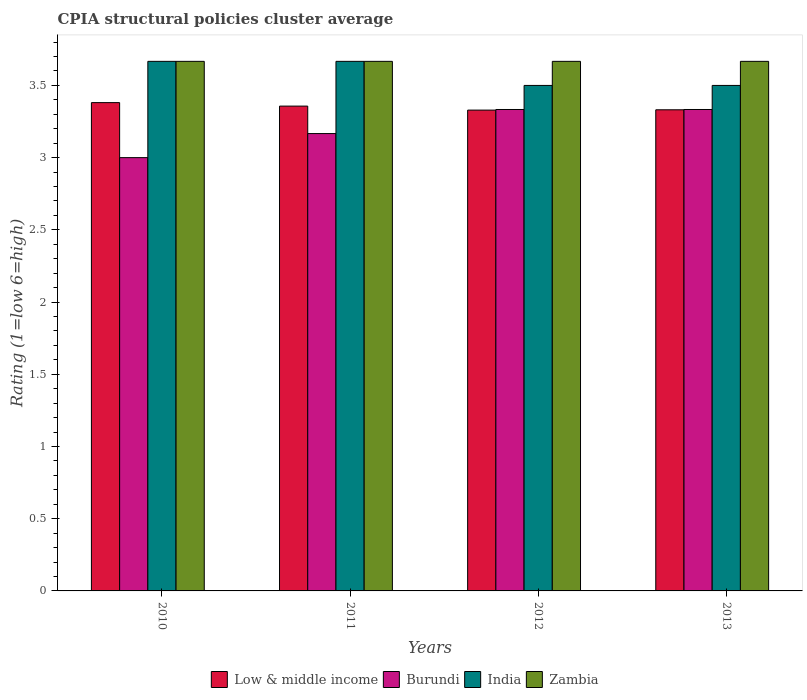What is the label of the 2nd group of bars from the left?
Your response must be concise. 2011. In how many cases, is the number of bars for a given year not equal to the number of legend labels?
Ensure brevity in your answer.  0. What is the CPIA rating in India in 2010?
Provide a short and direct response. 3.67. Across all years, what is the maximum CPIA rating in Zambia?
Offer a terse response. 3.67. In which year was the CPIA rating in India maximum?
Your answer should be very brief. 2010. What is the total CPIA rating in Low & middle income in the graph?
Offer a very short reply. 13.4. What is the difference between the CPIA rating in Low & middle income in 2011 and that in 2012?
Provide a succinct answer. 0.03. What is the difference between the CPIA rating in Zambia in 2010 and the CPIA rating in Low & middle income in 2013?
Provide a short and direct response. 0.34. What is the average CPIA rating in Low & middle income per year?
Ensure brevity in your answer.  3.35. In the year 2011, what is the difference between the CPIA rating in India and CPIA rating in Zambia?
Keep it short and to the point. 0. In how many years, is the CPIA rating in Burundi greater than 1.1?
Your answer should be very brief. 4. What is the ratio of the CPIA rating in Low & middle income in 2012 to that in 2013?
Offer a very short reply. 1. Is the difference between the CPIA rating in India in 2010 and 2013 greater than the difference between the CPIA rating in Zambia in 2010 and 2013?
Give a very brief answer. Yes. What is the difference between the highest and the lowest CPIA rating in Burundi?
Your response must be concise. 0.33. Is it the case that in every year, the sum of the CPIA rating in Burundi and CPIA rating in Zambia is greater than the sum of CPIA rating in Low & middle income and CPIA rating in India?
Keep it short and to the point. No. What does the 4th bar from the left in 2012 represents?
Give a very brief answer. Zambia. What does the 2nd bar from the right in 2012 represents?
Your response must be concise. India. What is the difference between two consecutive major ticks on the Y-axis?
Your response must be concise. 0.5. Does the graph contain any zero values?
Your answer should be very brief. No. How are the legend labels stacked?
Provide a short and direct response. Horizontal. What is the title of the graph?
Ensure brevity in your answer.  CPIA structural policies cluster average. What is the label or title of the X-axis?
Offer a terse response. Years. What is the Rating (1=low 6=high) of Low & middle income in 2010?
Offer a terse response. 3.38. What is the Rating (1=low 6=high) in Burundi in 2010?
Give a very brief answer. 3. What is the Rating (1=low 6=high) of India in 2010?
Offer a very short reply. 3.67. What is the Rating (1=low 6=high) of Zambia in 2010?
Ensure brevity in your answer.  3.67. What is the Rating (1=low 6=high) in Low & middle income in 2011?
Provide a short and direct response. 3.36. What is the Rating (1=low 6=high) of Burundi in 2011?
Your response must be concise. 3.17. What is the Rating (1=low 6=high) of India in 2011?
Offer a very short reply. 3.67. What is the Rating (1=low 6=high) of Zambia in 2011?
Provide a succinct answer. 3.67. What is the Rating (1=low 6=high) of Low & middle income in 2012?
Provide a short and direct response. 3.33. What is the Rating (1=low 6=high) in Burundi in 2012?
Your answer should be very brief. 3.33. What is the Rating (1=low 6=high) in India in 2012?
Your answer should be very brief. 3.5. What is the Rating (1=low 6=high) in Zambia in 2012?
Offer a very short reply. 3.67. What is the Rating (1=low 6=high) of Low & middle income in 2013?
Your answer should be very brief. 3.33. What is the Rating (1=low 6=high) in Burundi in 2013?
Keep it short and to the point. 3.33. What is the Rating (1=low 6=high) in Zambia in 2013?
Your answer should be compact. 3.67. Across all years, what is the maximum Rating (1=low 6=high) of Low & middle income?
Your response must be concise. 3.38. Across all years, what is the maximum Rating (1=low 6=high) of Burundi?
Your response must be concise. 3.33. Across all years, what is the maximum Rating (1=low 6=high) of India?
Offer a very short reply. 3.67. Across all years, what is the maximum Rating (1=low 6=high) in Zambia?
Make the answer very short. 3.67. Across all years, what is the minimum Rating (1=low 6=high) of Low & middle income?
Provide a succinct answer. 3.33. Across all years, what is the minimum Rating (1=low 6=high) in Zambia?
Give a very brief answer. 3.67. What is the total Rating (1=low 6=high) of Low & middle income in the graph?
Make the answer very short. 13.4. What is the total Rating (1=low 6=high) of Burundi in the graph?
Offer a terse response. 12.83. What is the total Rating (1=low 6=high) of India in the graph?
Give a very brief answer. 14.33. What is the total Rating (1=low 6=high) in Zambia in the graph?
Offer a terse response. 14.67. What is the difference between the Rating (1=low 6=high) in Low & middle income in 2010 and that in 2011?
Keep it short and to the point. 0.02. What is the difference between the Rating (1=low 6=high) of India in 2010 and that in 2011?
Provide a short and direct response. 0. What is the difference between the Rating (1=low 6=high) of Zambia in 2010 and that in 2011?
Make the answer very short. 0. What is the difference between the Rating (1=low 6=high) of Low & middle income in 2010 and that in 2012?
Make the answer very short. 0.05. What is the difference between the Rating (1=low 6=high) in Burundi in 2010 and that in 2012?
Give a very brief answer. -0.33. What is the difference between the Rating (1=low 6=high) in India in 2010 and that in 2012?
Make the answer very short. 0.17. What is the difference between the Rating (1=low 6=high) in Zambia in 2010 and that in 2012?
Offer a terse response. 0. What is the difference between the Rating (1=low 6=high) in Low & middle income in 2010 and that in 2013?
Make the answer very short. 0.05. What is the difference between the Rating (1=low 6=high) in Burundi in 2010 and that in 2013?
Your response must be concise. -0.33. What is the difference between the Rating (1=low 6=high) of India in 2010 and that in 2013?
Offer a very short reply. 0.17. What is the difference between the Rating (1=low 6=high) of Low & middle income in 2011 and that in 2012?
Make the answer very short. 0.03. What is the difference between the Rating (1=low 6=high) of India in 2011 and that in 2012?
Offer a very short reply. 0.17. What is the difference between the Rating (1=low 6=high) in Zambia in 2011 and that in 2012?
Provide a short and direct response. 0. What is the difference between the Rating (1=low 6=high) in Low & middle income in 2011 and that in 2013?
Your answer should be compact. 0.03. What is the difference between the Rating (1=low 6=high) in Burundi in 2011 and that in 2013?
Make the answer very short. -0.17. What is the difference between the Rating (1=low 6=high) of India in 2011 and that in 2013?
Offer a terse response. 0.17. What is the difference between the Rating (1=low 6=high) in Zambia in 2011 and that in 2013?
Your answer should be compact. 0. What is the difference between the Rating (1=low 6=high) in Low & middle income in 2012 and that in 2013?
Provide a succinct answer. -0. What is the difference between the Rating (1=low 6=high) in Burundi in 2012 and that in 2013?
Make the answer very short. 0. What is the difference between the Rating (1=low 6=high) of India in 2012 and that in 2013?
Provide a short and direct response. 0. What is the difference between the Rating (1=low 6=high) of Zambia in 2012 and that in 2013?
Provide a short and direct response. 0. What is the difference between the Rating (1=low 6=high) of Low & middle income in 2010 and the Rating (1=low 6=high) of Burundi in 2011?
Offer a terse response. 0.21. What is the difference between the Rating (1=low 6=high) of Low & middle income in 2010 and the Rating (1=low 6=high) of India in 2011?
Your response must be concise. -0.29. What is the difference between the Rating (1=low 6=high) in Low & middle income in 2010 and the Rating (1=low 6=high) in Zambia in 2011?
Ensure brevity in your answer.  -0.29. What is the difference between the Rating (1=low 6=high) in Low & middle income in 2010 and the Rating (1=low 6=high) in Burundi in 2012?
Keep it short and to the point. 0.05. What is the difference between the Rating (1=low 6=high) in Low & middle income in 2010 and the Rating (1=low 6=high) in India in 2012?
Your answer should be very brief. -0.12. What is the difference between the Rating (1=low 6=high) in Low & middle income in 2010 and the Rating (1=low 6=high) in Zambia in 2012?
Offer a very short reply. -0.29. What is the difference between the Rating (1=low 6=high) of Burundi in 2010 and the Rating (1=low 6=high) of India in 2012?
Offer a terse response. -0.5. What is the difference between the Rating (1=low 6=high) in Burundi in 2010 and the Rating (1=low 6=high) in Zambia in 2012?
Keep it short and to the point. -0.67. What is the difference between the Rating (1=low 6=high) in Low & middle income in 2010 and the Rating (1=low 6=high) in Burundi in 2013?
Give a very brief answer. 0.05. What is the difference between the Rating (1=low 6=high) in Low & middle income in 2010 and the Rating (1=low 6=high) in India in 2013?
Ensure brevity in your answer.  -0.12. What is the difference between the Rating (1=low 6=high) of Low & middle income in 2010 and the Rating (1=low 6=high) of Zambia in 2013?
Your response must be concise. -0.29. What is the difference between the Rating (1=low 6=high) in Burundi in 2010 and the Rating (1=low 6=high) in India in 2013?
Keep it short and to the point. -0.5. What is the difference between the Rating (1=low 6=high) in India in 2010 and the Rating (1=low 6=high) in Zambia in 2013?
Offer a terse response. 0. What is the difference between the Rating (1=low 6=high) of Low & middle income in 2011 and the Rating (1=low 6=high) of Burundi in 2012?
Offer a very short reply. 0.02. What is the difference between the Rating (1=low 6=high) in Low & middle income in 2011 and the Rating (1=low 6=high) in India in 2012?
Keep it short and to the point. -0.14. What is the difference between the Rating (1=low 6=high) of Low & middle income in 2011 and the Rating (1=low 6=high) of Zambia in 2012?
Provide a short and direct response. -0.31. What is the difference between the Rating (1=low 6=high) of India in 2011 and the Rating (1=low 6=high) of Zambia in 2012?
Provide a succinct answer. 0. What is the difference between the Rating (1=low 6=high) of Low & middle income in 2011 and the Rating (1=low 6=high) of Burundi in 2013?
Your answer should be very brief. 0.02. What is the difference between the Rating (1=low 6=high) in Low & middle income in 2011 and the Rating (1=low 6=high) in India in 2013?
Provide a succinct answer. -0.14. What is the difference between the Rating (1=low 6=high) of Low & middle income in 2011 and the Rating (1=low 6=high) of Zambia in 2013?
Your answer should be very brief. -0.31. What is the difference between the Rating (1=low 6=high) in Burundi in 2011 and the Rating (1=low 6=high) in India in 2013?
Keep it short and to the point. -0.33. What is the difference between the Rating (1=low 6=high) of Low & middle income in 2012 and the Rating (1=low 6=high) of Burundi in 2013?
Keep it short and to the point. -0. What is the difference between the Rating (1=low 6=high) in Low & middle income in 2012 and the Rating (1=low 6=high) in India in 2013?
Keep it short and to the point. -0.17. What is the difference between the Rating (1=low 6=high) in Low & middle income in 2012 and the Rating (1=low 6=high) in Zambia in 2013?
Your response must be concise. -0.34. What is the difference between the Rating (1=low 6=high) in Burundi in 2012 and the Rating (1=low 6=high) in India in 2013?
Make the answer very short. -0.17. What is the average Rating (1=low 6=high) in Low & middle income per year?
Your answer should be very brief. 3.35. What is the average Rating (1=low 6=high) in Burundi per year?
Provide a succinct answer. 3.21. What is the average Rating (1=low 6=high) of India per year?
Provide a succinct answer. 3.58. What is the average Rating (1=low 6=high) of Zambia per year?
Keep it short and to the point. 3.67. In the year 2010, what is the difference between the Rating (1=low 6=high) in Low & middle income and Rating (1=low 6=high) in Burundi?
Provide a succinct answer. 0.38. In the year 2010, what is the difference between the Rating (1=low 6=high) in Low & middle income and Rating (1=low 6=high) in India?
Offer a terse response. -0.29. In the year 2010, what is the difference between the Rating (1=low 6=high) of Low & middle income and Rating (1=low 6=high) of Zambia?
Provide a short and direct response. -0.29. In the year 2010, what is the difference between the Rating (1=low 6=high) of India and Rating (1=low 6=high) of Zambia?
Your response must be concise. 0. In the year 2011, what is the difference between the Rating (1=low 6=high) of Low & middle income and Rating (1=low 6=high) of Burundi?
Provide a succinct answer. 0.19. In the year 2011, what is the difference between the Rating (1=low 6=high) of Low & middle income and Rating (1=low 6=high) of India?
Offer a terse response. -0.31. In the year 2011, what is the difference between the Rating (1=low 6=high) of Low & middle income and Rating (1=low 6=high) of Zambia?
Make the answer very short. -0.31. In the year 2011, what is the difference between the Rating (1=low 6=high) of India and Rating (1=low 6=high) of Zambia?
Your answer should be very brief. 0. In the year 2012, what is the difference between the Rating (1=low 6=high) in Low & middle income and Rating (1=low 6=high) in Burundi?
Your answer should be compact. -0. In the year 2012, what is the difference between the Rating (1=low 6=high) in Low & middle income and Rating (1=low 6=high) in India?
Give a very brief answer. -0.17. In the year 2012, what is the difference between the Rating (1=low 6=high) in Low & middle income and Rating (1=low 6=high) in Zambia?
Offer a terse response. -0.34. In the year 2012, what is the difference between the Rating (1=low 6=high) of Burundi and Rating (1=low 6=high) of Zambia?
Your answer should be compact. -0.33. In the year 2012, what is the difference between the Rating (1=low 6=high) of India and Rating (1=low 6=high) of Zambia?
Your answer should be very brief. -0.17. In the year 2013, what is the difference between the Rating (1=low 6=high) in Low & middle income and Rating (1=low 6=high) in Burundi?
Offer a terse response. -0. In the year 2013, what is the difference between the Rating (1=low 6=high) of Low & middle income and Rating (1=low 6=high) of India?
Your response must be concise. -0.17. In the year 2013, what is the difference between the Rating (1=low 6=high) of Low & middle income and Rating (1=low 6=high) of Zambia?
Your answer should be very brief. -0.34. In the year 2013, what is the difference between the Rating (1=low 6=high) in Burundi and Rating (1=low 6=high) in India?
Offer a very short reply. -0.17. In the year 2013, what is the difference between the Rating (1=low 6=high) in India and Rating (1=low 6=high) in Zambia?
Offer a very short reply. -0.17. What is the ratio of the Rating (1=low 6=high) of Low & middle income in 2010 to that in 2011?
Your answer should be very brief. 1.01. What is the ratio of the Rating (1=low 6=high) of Burundi in 2010 to that in 2011?
Your answer should be very brief. 0.95. What is the ratio of the Rating (1=low 6=high) in Zambia in 2010 to that in 2011?
Keep it short and to the point. 1. What is the ratio of the Rating (1=low 6=high) in Low & middle income in 2010 to that in 2012?
Ensure brevity in your answer.  1.02. What is the ratio of the Rating (1=low 6=high) in India in 2010 to that in 2012?
Offer a terse response. 1.05. What is the ratio of the Rating (1=low 6=high) of Low & middle income in 2010 to that in 2013?
Keep it short and to the point. 1.01. What is the ratio of the Rating (1=low 6=high) of India in 2010 to that in 2013?
Keep it short and to the point. 1.05. What is the ratio of the Rating (1=low 6=high) in Zambia in 2010 to that in 2013?
Provide a succinct answer. 1. What is the ratio of the Rating (1=low 6=high) in Low & middle income in 2011 to that in 2012?
Offer a very short reply. 1.01. What is the ratio of the Rating (1=low 6=high) in India in 2011 to that in 2012?
Your answer should be compact. 1.05. What is the ratio of the Rating (1=low 6=high) in Low & middle income in 2011 to that in 2013?
Give a very brief answer. 1.01. What is the ratio of the Rating (1=low 6=high) in Burundi in 2011 to that in 2013?
Ensure brevity in your answer.  0.95. What is the ratio of the Rating (1=low 6=high) in India in 2011 to that in 2013?
Offer a very short reply. 1.05. What is the ratio of the Rating (1=low 6=high) in Low & middle income in 2012 to that in 2013?
Offer a very short reply. 1. What is the ratio of the Rating (1=low 6=high) in Zambia in 2012 to that in 2013?
Keep it short and to the point. 1. What is the difference between the highest and the second highest Rating (1=low 6=high) in Low & middle income?
Ensure brevity in your answer.  0.02. What is the difference between the highest and the second highest Rating (1=low 6=high) in Burundi?
Offer a terse response. 0. What is the difference between the highest and the lowest Rating (1=low 6=high) in Low & middle income?
Keep it short and to the point. 0.05. What is the difference between the highest and the lowest Rating (1=low 6=high) of Burundi?
Keep it short and to the point. 0.33. What is the difference between the highest and the lowest Rating (1=low 6=high) of India?
Provide a succinct answer. 0.17. 